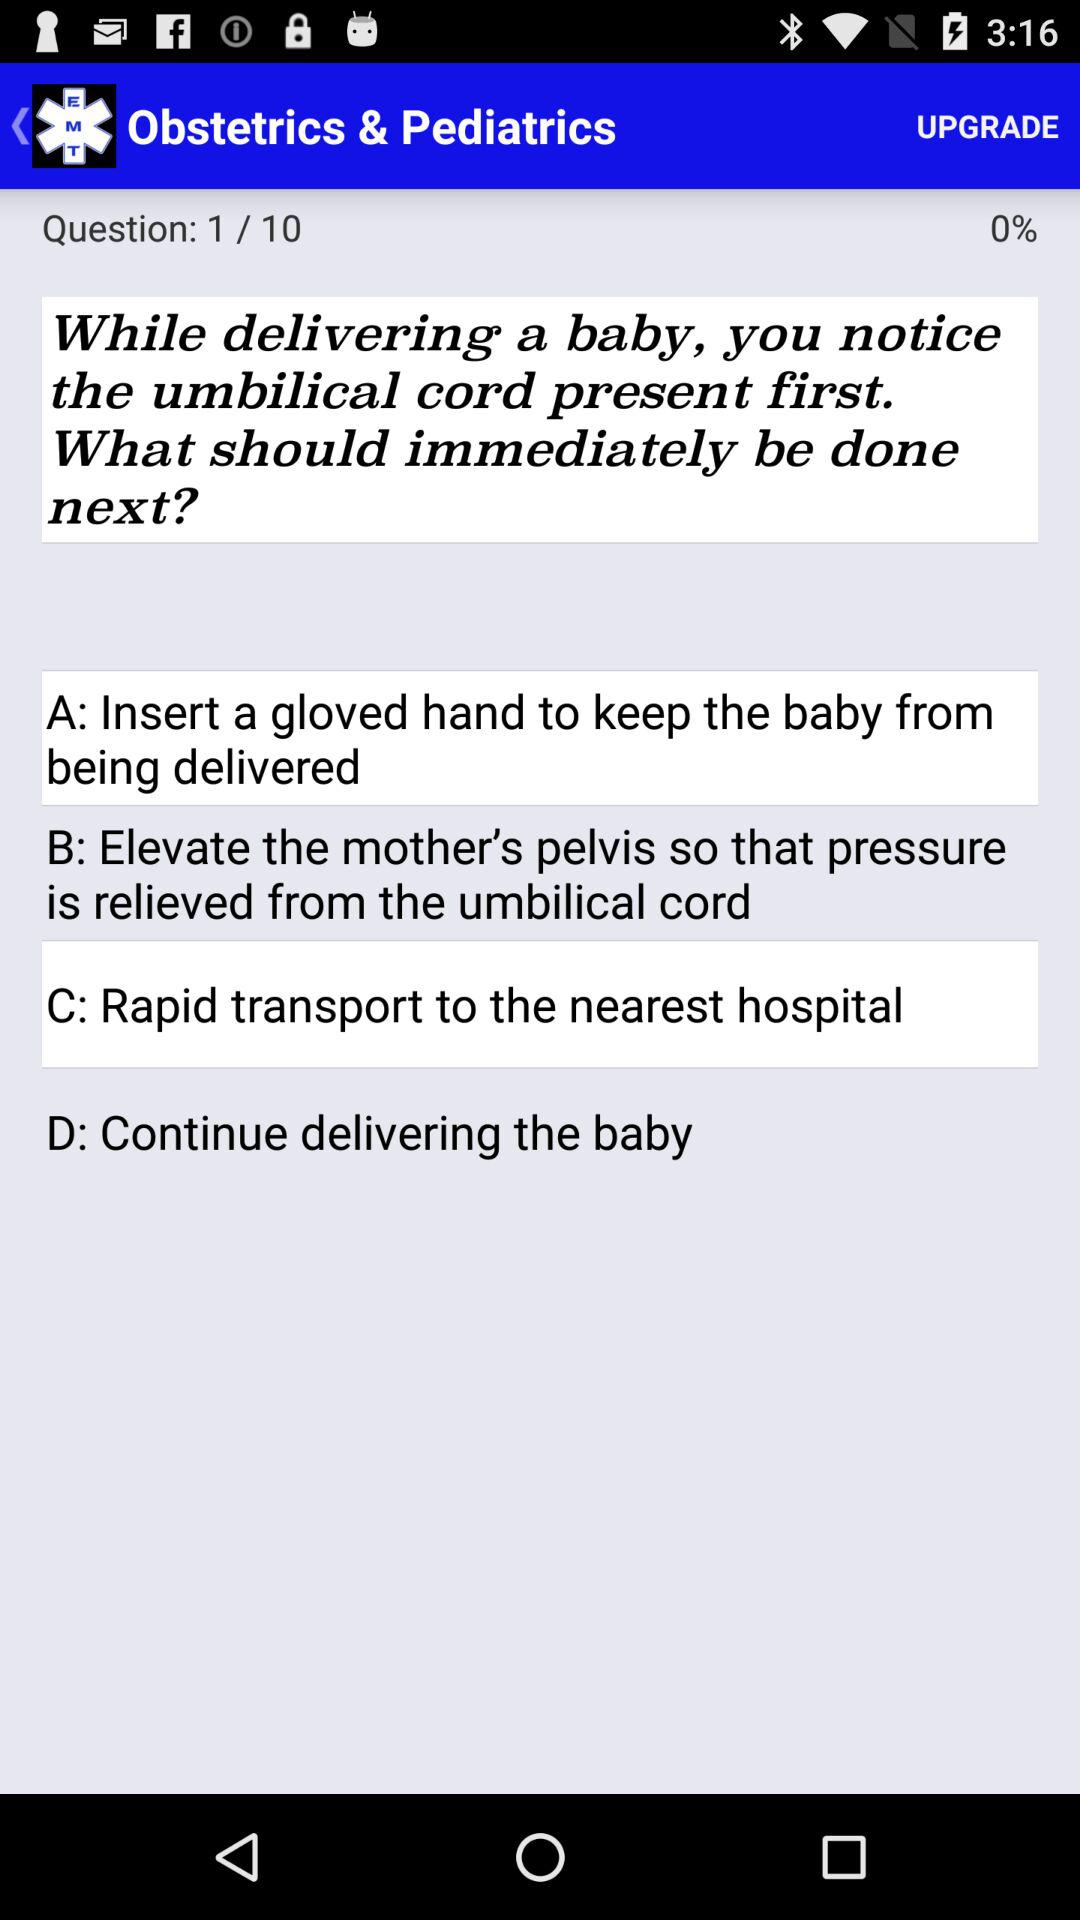How many options are there in the multiple choice question?
Answer the question using a single word or phrase. 4 